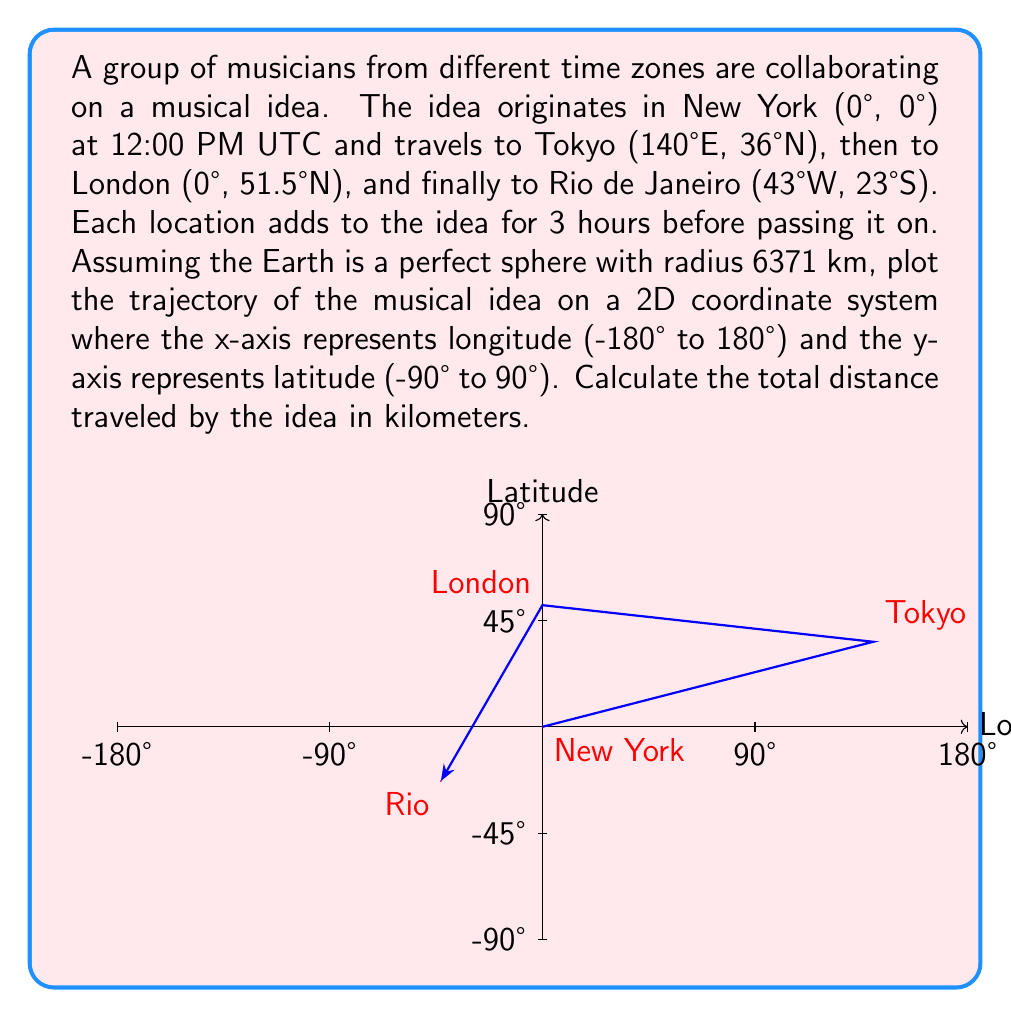Teach me how to tackle this problem. To solve this problem, we'll follow these steps:

1) Convert latitude and longitude to radians:
   New York: $(0, 0)$
   Tokyo: $(140 \cdot \frac{\pi}{180}, 36 \cdot \frac{\pi}{180})$
   London: $(0, 51.5 \cdot \frac{\pi}{180})$
   Rio: $(-43 \cdot \frac{\pi}{180}, -23 \cdot \frac{\pi}{180})$

2) Calculate the great circle distance between each pair of points using the haversine formula:

   $d = 2R \cdot \arcsin(\sqrt{\sin^2(\frac{\Delta\phi}{2}) + \cos\phi_1 \cdot \cos\phi_2 \cdot \sin^2(\frac{\Delta\lambda}{2})})$

   Where:
   $R$ is the Earth's radius (6371 km)
   $\phi$ is latitude
   $\lambda$ is longitude
   $\Delta\phi$ is the difference in latitude
   $\Delta\lambda$ is the difference in longitude

3) New York to Tokyo:
   $$d_1 = 2 \cdot 6371 \cdot \arcsin(\sqrt{\sin^2(\frac{36\pi/180}{2}) + \cos(0) \cdot \cos(36\pi/180) \cdot \sin^2(\frac{140\pi/180}{2})})$$
   $$d_1 \approx 10,878 \text{ km}$$

4) Tokyo to London:
   $$d_2 = 2 \cdot 6371 \cdot \arcsin(\sqrt{\sin^2(\frac{(51.5-36)\pi/180}{2}) + \cos(36\pi/180) \cdot \cos(51.5\pi/180) \cdot \sin^2(\frac{-140\pi/180}{2})})$$
   $$d_2 \approx 9,559 \text{ km}$$

5) London to Rio:
   $$d_3 = 2 \cdot 6371 \cdot \arcsin(\sqrt{\sin^2(\frac{(-23-51.5)\pi/180}{2}) + \cos(51.5\pi/180) \cdot \cos(-23\pi/180) \cdot \sin^2(\frac{-43\pi/180}{2})})$$
   $$d_3 \approx 9,256 \text{ km}$$

6) Total distance:
   $$d_{total} = d_1 + d_2 + d_3 = 10,878 + 9,559 + 9,256 = 29,693 \text{ km}$$

The trajectory is plotted on the 2D coordinate system as shown in the figure, connecting the points in the order: New York -> Tokyo -> London -> Rio.
Answer: 29,693 km 